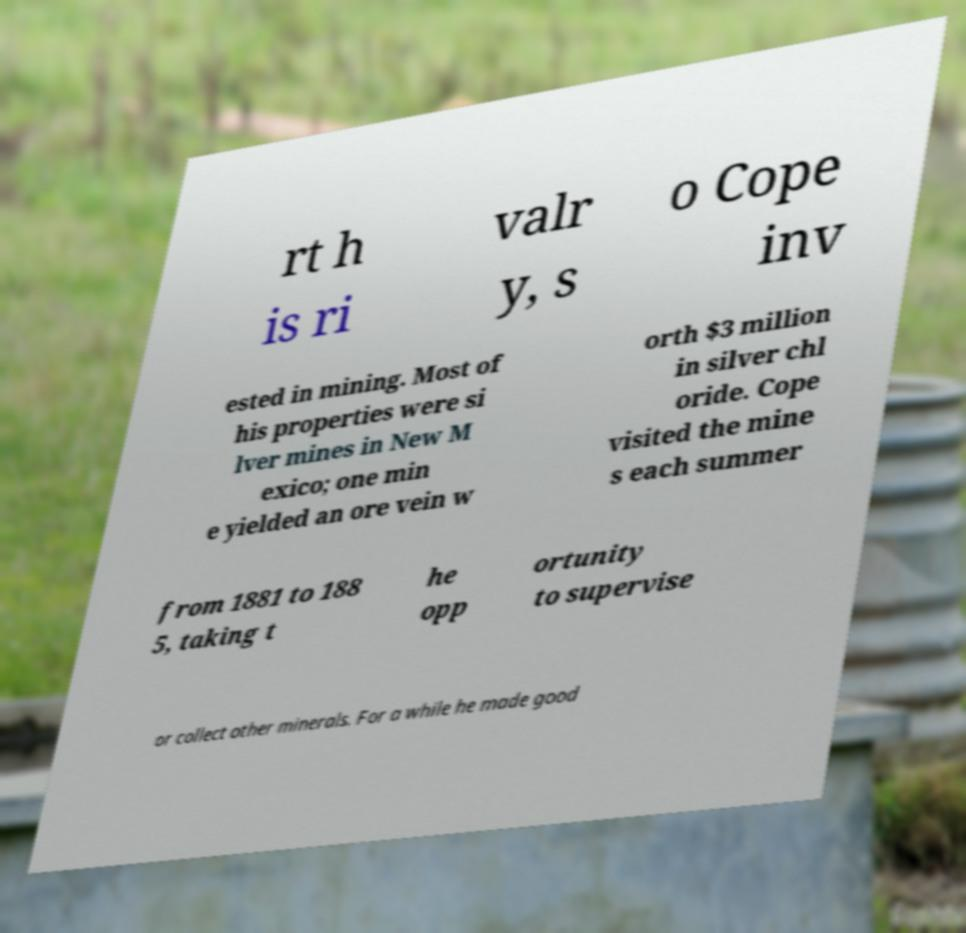Please read and relay the text visible in this image. What does it say? rt h is ri valr y, s o Cope inv ested in mining. Most of his properties were si lver mines in New M exico; one min e yielded an ore vein w orth $3 million in silver chl oride. Cope visited the mine s each summer from 1881 to 188 5, taking t he opp ortunity to supervise or collect other minerals. For a while he made good 